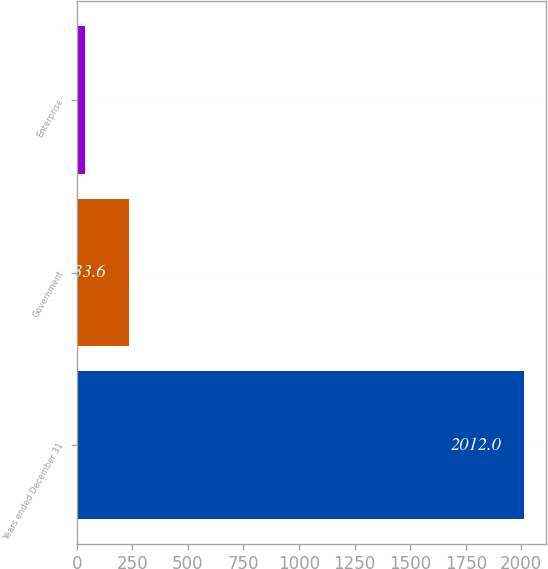<chart> <loc_0><loc_0><loc_500><loc_500><bar_chart><fcel>Years ended December 31<fcel>Government<fcel>Enterprise<nl><fcel>2012<fcel>233.6<fcel>36<nl></chart> 